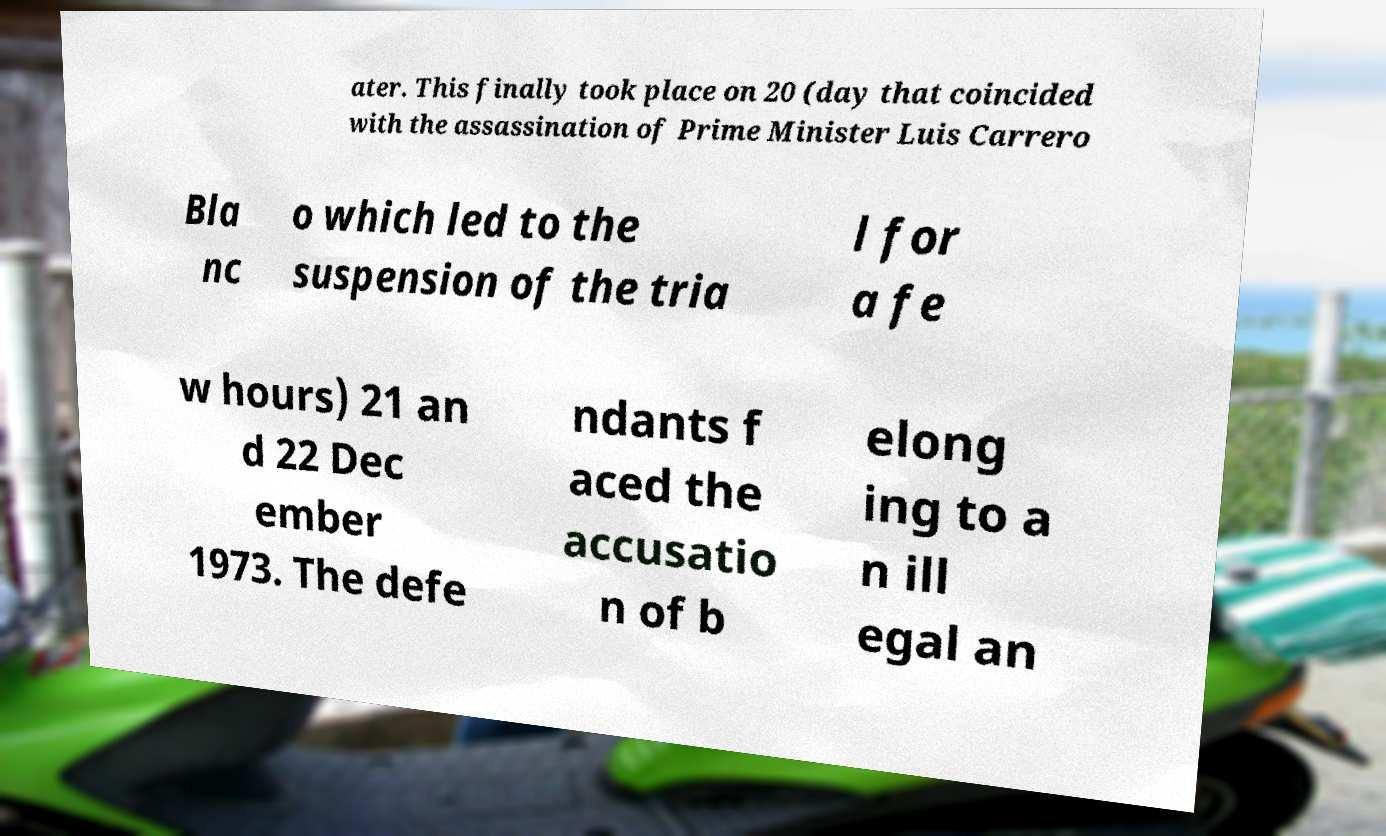There's text embedded in this image that I need extracted. Can you transcribe it verbatim? ater. This finally took place on 20 (day that coincided with the assassination of Prime Minister Luis Carrero Bla nc o which led to the suspension of the tria l for a fe w hours) 21 an d 22 Dec ember 1973. The defe ndants f aced the accusatio n of b elong ing to a n ill egal an 